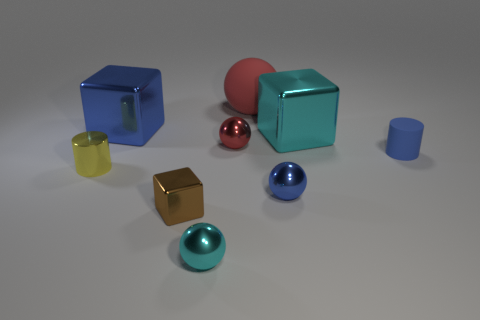Subtract 1 spheres. How many spheres are left? 3 Add 1 cyan spheres. How many objects exist? 10 Subtract all cubes. How many objects are left? 6 Subtract 1 blue cubes. How many objects are left? 8 Subtract all big blue things. Subtract all yellow metal objects. How many objects are left? 7 Add 6 cyan metallic objects. How many cyan metallic objects are left? 8 Add 3 tiny metal cylinders. How many tiny metal cylinders exist? 4 